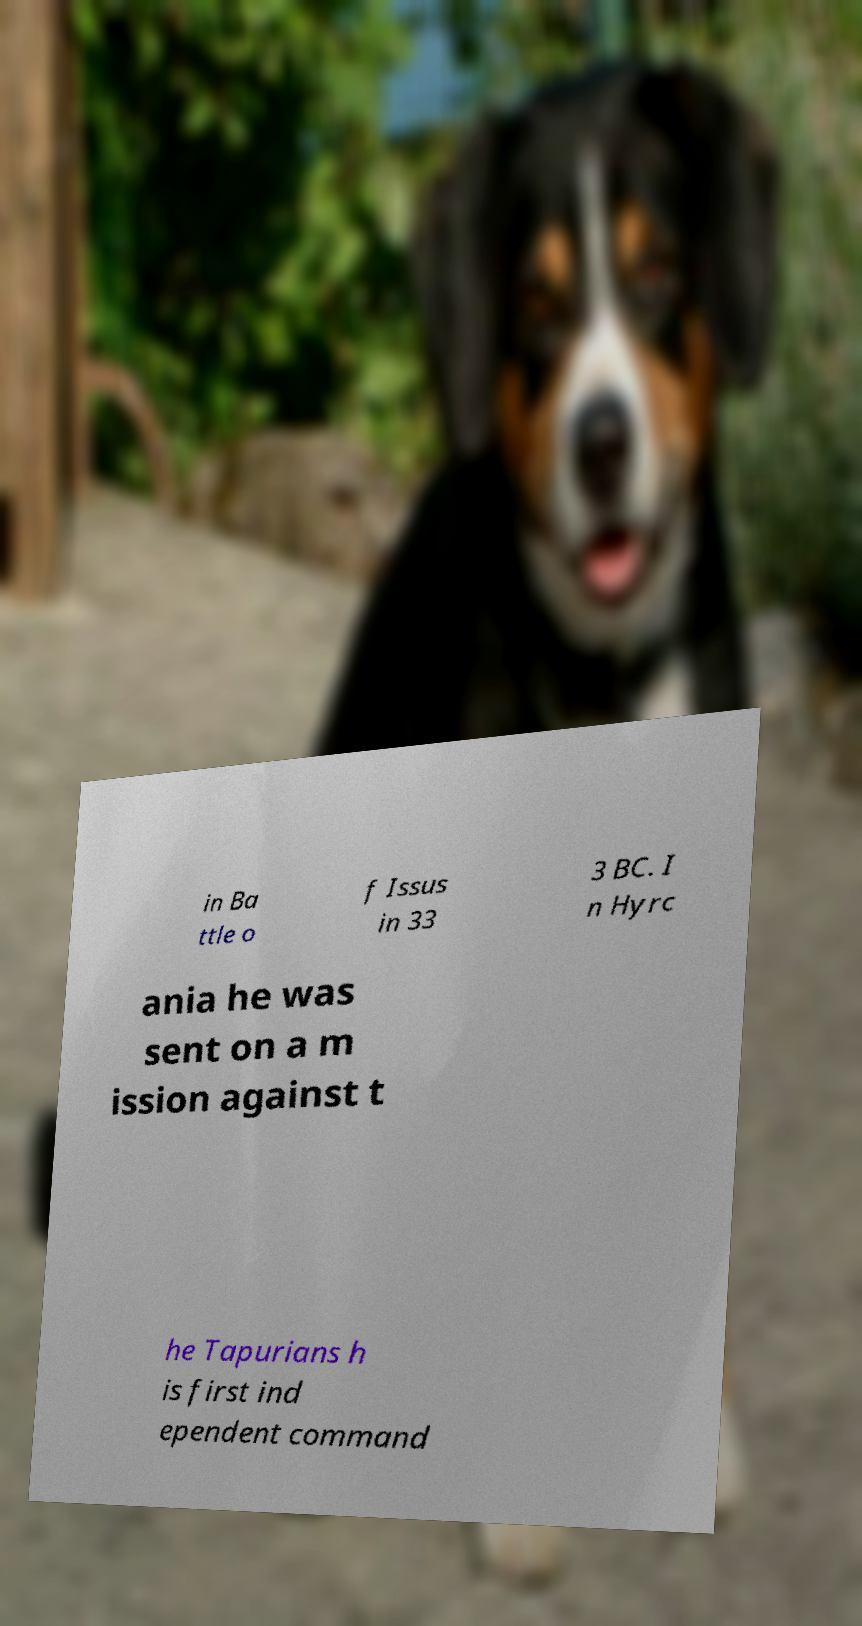There's text embedded in this image that I need extracted. Can you transcribe it verbatim? in Ba ttle o f Issus in 33 3 BC. I n Hyrc ania he was sent on a m ission against t he Tapurians h is first ind ependent command 